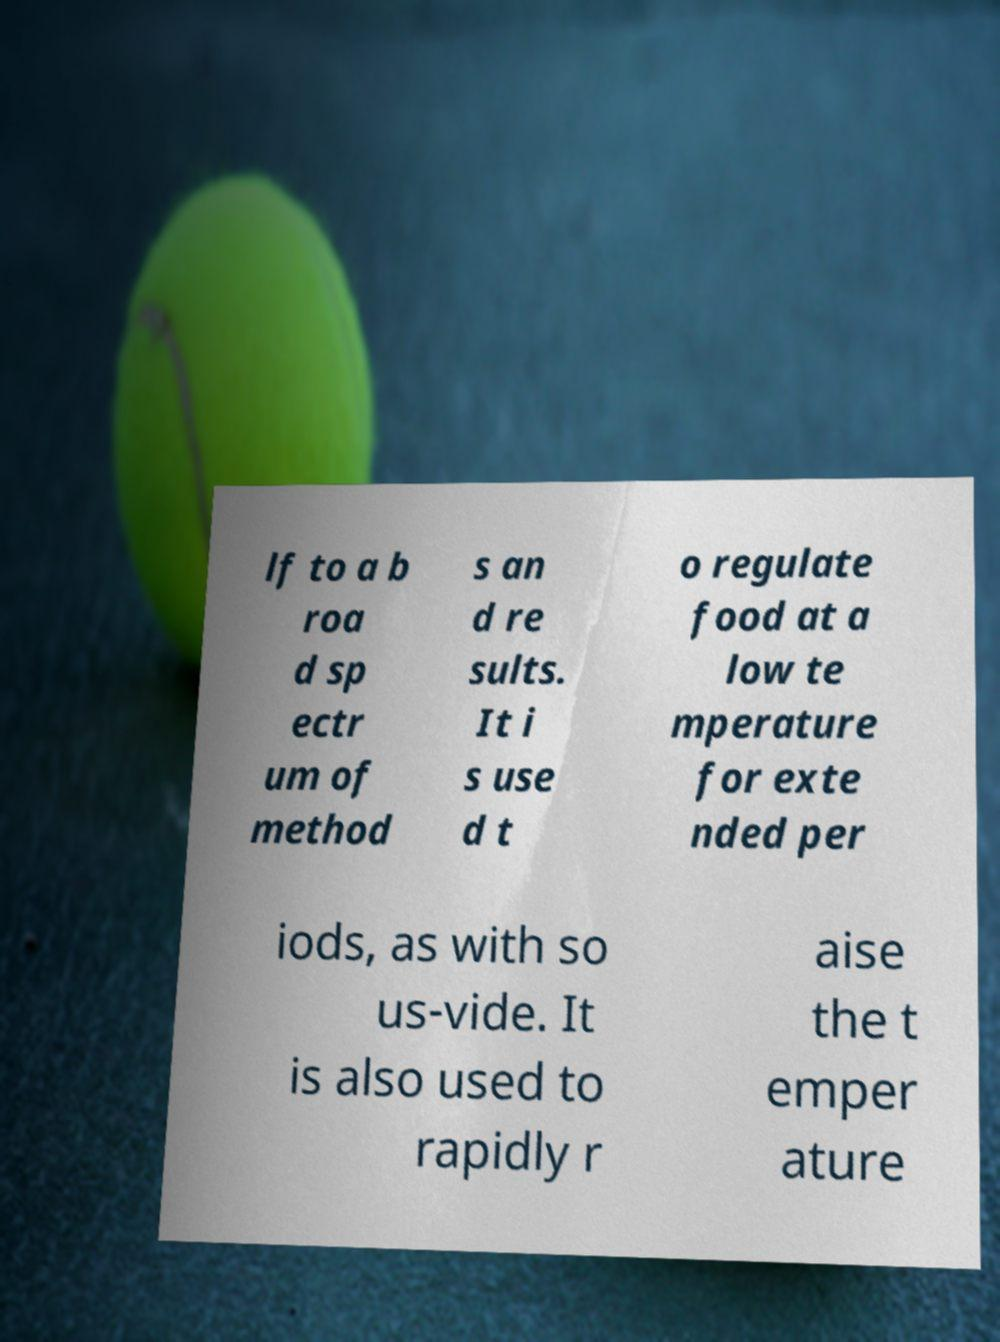Please identify and transcribe the text found in this image. lf to a b roa d sp ectr um of method s an d re sults. It i s use d t o regulate food at a low te mperature for exte nded per iods, as with so us-vide. It is also used to rapidly r aise the t emper ature 